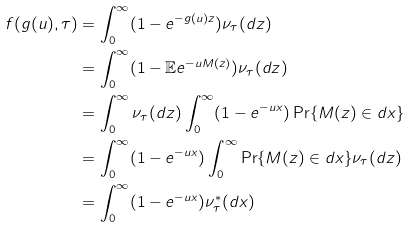<formula> <loc_0><loc_0><loc_500><loc_500>f ( g ( u ) , \tau ) & = \int _ { 0 } ^ { \infty } ( 1 - e ^ { - g ( u ) z } ) \nu _ { \tau } ( d z ) \\ & = \int _ { 0 } ^ { \infty } ( 1 - \mathbb { E } e ^ { - u M ( z ) } ) \nu _ { \tau } ( d z ) \\ & = \int _ { 0 } ^ { \infty } \nu _ { \tau } ( d z ) \int _ { 0 } ^ { \infty } ( 1 - e ^ { - u x } ) \Pr \{ M ( z ) \in d x \} \\ & = \int _ { 0 } ^ { \infty } ( 1 - e ^ { - u x } ) \int _ { 0 } ^ { \infty } \Pr \{ M ( z ) \in d x \} \nu _ { \tau } ( d z ) \\ & = \int _ { 0 } ^ { \infty } ( 1 - e ^ { - u x } ) \nu ^ { * } _ { \tau } ( d x )</formula> 